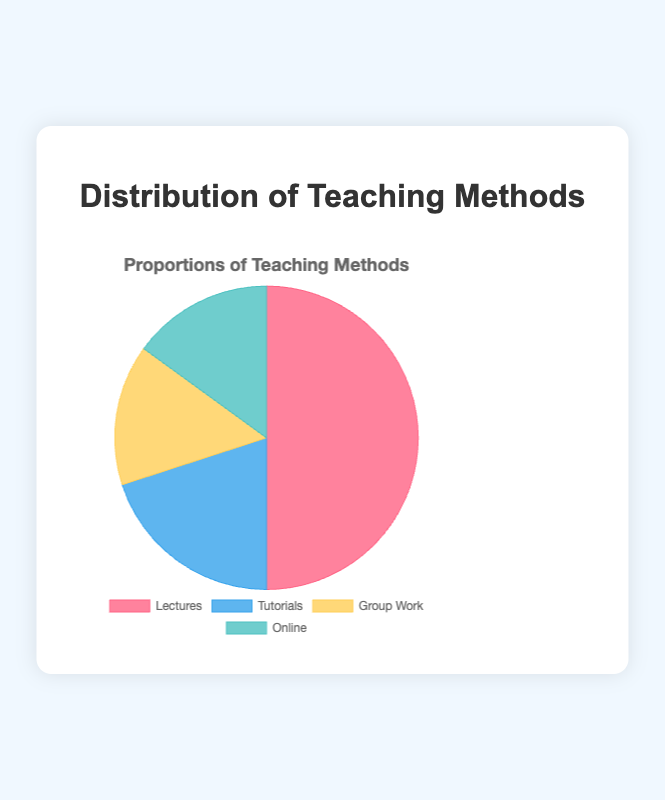What percentage of teaching methods consists of individual (not group) based learning? Lectures and Tutorials are individual-based teaching methods. Adding the percentages of Lectures (50%) and Tutorials (20%) gives 70%.
Answer: 70% Which teaching method is used the most? From the pie chart, the teaching method with the largest proportion is Lectures, which is 50%.
Answer: Lectures How do the proportions of Group Work and Online methods compare? Both Group Work and Online methods make up 15% each, indicating they are used equally.
Answer: Equal What is the total percentage of non-lecture-based teaching methods? Tutorials (20%), Group Work (15%), and Online (15%) are the non-lecture-based methods. Adding them up: 20% + 15% + 15% = 50%.
Answer: 50% What color represents the Group Work teaching method? From the pie chart, Group Work is represented by the yellow segment.
Answer: Yellow Which teaching method has the smallest proportion, and by how much is it smaller than Lectures? Both Group Work and Online have the smallest proportion (15%). The difference between Lectures (50%) and these methods is 50% - 15% = 35%.
Answer: Group Work and Online, 35% How much greater is the combined proportion of Tutorials and Online methods compared to Group Work? Tutorials (20%) and Online (15%) combined make 35%. Group Work is 15%. The difference is 35% - 15% = 20%.
Answer: 20% Arrange the teaching methods in descending order of their proportions. The proportions from highest to lowest are: Lectures (50%), Tutorials (20%), Group Work (15%), Online (15%).
Answer: Lectures, Tutorials, Group Work, Online What is the average proportion of the four teaching methods? Sum the proportions: 50% + 20% + 15% + 15% = 100%. Divide by 4 (number of methods) to get the average: 100% / 4 = 25%.
Answer: 25% 